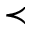Convert formula to latex. <formula><loc_0><loc_0><loc_500><loc_500>\prec</formula> 